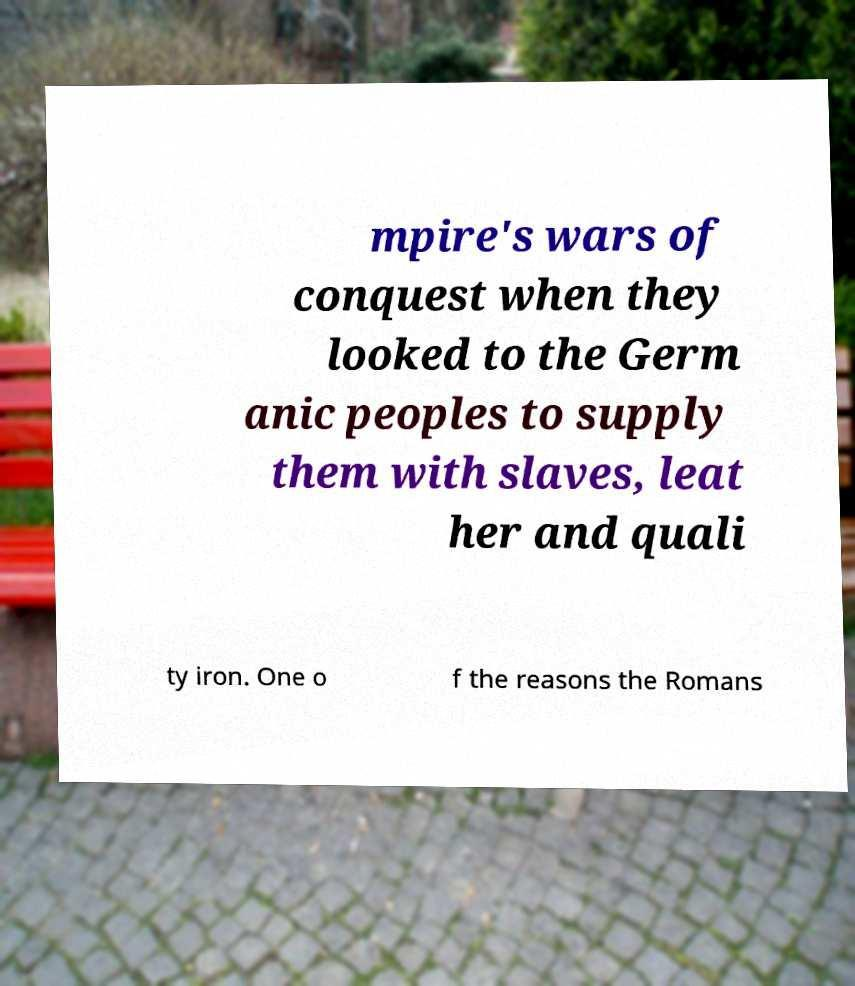Please identify and transcribe the text found in this image. mpire's wars of conquest when they looked to the Germ anic peoples to supply them with slaves, leat her and quali ty iron. One o f the reasons the Romans 